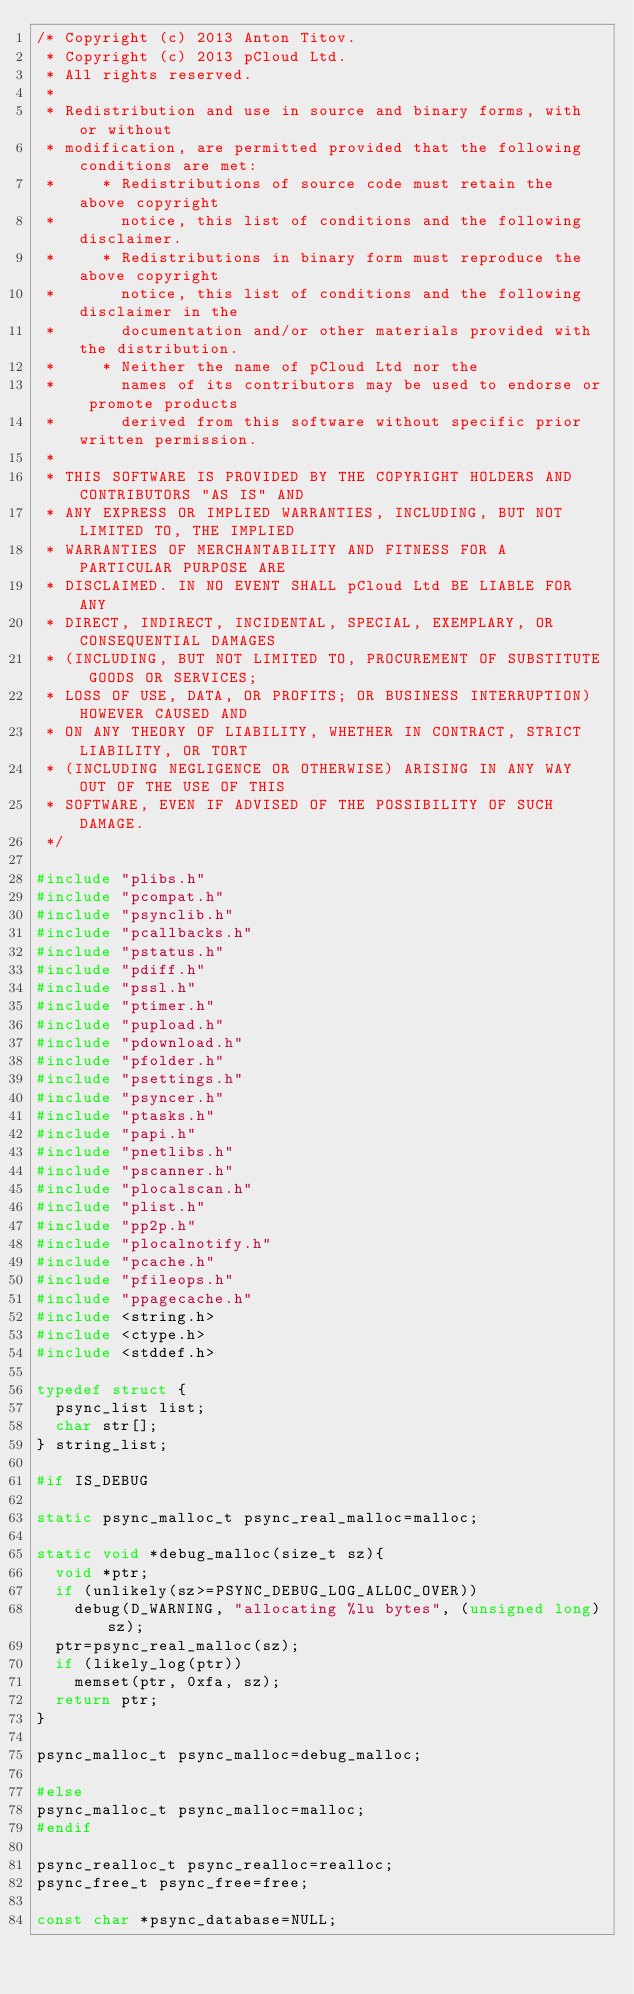Convert code to text. <code><loc_0><loc_0><loc_500><loc_500><_C_>/* Copyright (c) 2013 Anton Titov.
 * Copyright (c) 2013 pCloud Ltd.
 * All rights reserved.
 *
 * Redistribution and use in source and binary forms, with or without
 * modification, are permitted provided that the following conditions are met:
 *     * Redistributions of source code must retain the above copyright
 *       notice, this list of conditions and the following disclaimer.
 *     * Redistributions in binary form must reproduce the above copyright
 *       notice, this list of conditions and the following disclaimer in the
 *       documentation and/or other materials provided with the distribution.
 *     * Neither the name of pCloud Ltd nor the
 *       names of its contributors may be used to endorse or promote products
 *       derived from this software without specific prior written permission.
 *
 * THIS SOFTWARE IS PROVIDED BY THE COPYRIGHT HOLDERS AND CONTRIBUTORS "AS IS" AND
 * ANY EXPRESS OR IMPLIED WARRANTIES, INCLUDING, BUT NOT LIMITED TO, THE IMPLIED
 * WARRANTIES OF MERCHANTABILITY AND FITNESS FOR A PARTICULAR PURPOSE ARE
 * DISCLAIMED. IN NO EVENT SHALL pCloud Ltd BE LIABLE FOR ANY
 * DIRECT, INDIRECT, INCIDENTAL, SPECIAL, EXEMPLARY, OR CONSEQUENTIAL DAMAGES
 * (INCLUDING, BUT NOT LIMITED TO, PROCUREMENT OF SUBSTITUTE GOODS OR SERVICES;
 * LOSS OF USE, DATA, OR PROFITS; OR BUSINESS INTERRUPTION) HOWEVER CAUSED AND
 * ON ANY THEORY OF LIABILITY, WHETHER IN CONTRACT, STRICT LIABILITY, OR TORT
 * (INCLUDING NEGLIGENCE OR OTHERWISE) ARISING IN ANY WAY OUT OF THE USE OF THIS
 * SOFTWARE, EVEN IF ADVISED OF THE POSSIBILITY OF SUCH DAMAGE.
 */

#include "plibs.h"
#include "pcompat.h"
#include "psynclib.h"
#include "pcallbacks.h"
#include "pstatus.h"
#include "pdiff.h"
#include "pssl.h"
#include "ptimer.h"
#include "pupload.h"
#include "pdownload.h"
#include "pfolder.h"
#include "psettings.h"
#include "psyncer.h"
#include "ptasks.h"
#include "papi.h"
#include "pnetlibs.h"
#include "pscanner.h"
#include "plocalscan.h"
#include "plist.h"
#include "pp2p.h"
#include "plocalnotify.h"
#include "pcache.h"
#include "pfileops.h"
#include "ppagecache.h"
#include <string.h>
#include <ctype.h>
#include <stddef.h>

typedef struct {
  psync_list list;
  char str[];
} string_list;

#if IS_DEBUG

static psync_malloc_t psync_real_malloc=malloc;

static void *debug_malloc(size_t sz){
  void *ptr;
  if (unlikely(sz>=PSYNC_DEBUG_LOG_ALLOC_OVER))
    debug(D_WARNING, "allocating %lu bytes", (unsigned long)sz);
  ptr=psync_real_malloc(sz);
  if (likely_log(ptr))
    memset(ptr, 0xfa, sz);
  return ptr;
}

psync_malloc_t psync_malloc=debug_malloc;

#else
psync_malloc_t psync_malloc=malloc;
#endif

psync_realloc_t psync_realloc=realloc;
psync_free_t psync_free=free;

const char *psync_database=NULL;
</code> 